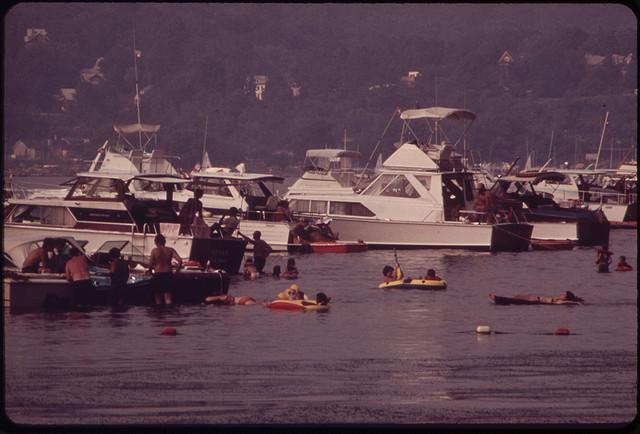What name is written on the fishing boat?
Short answer required. None. Do you think it's Summer?
Short answer required. Yes. What color is the sky?
Answer briefly. Gray. Is this picture in present time?
Quick response, please. No. Are there people in the water?
Give a very brief answer. Yes. Is this a recent photo?
Give a very brief answer. No. Why is there a reflection?
Be succinct. Sunlight. 